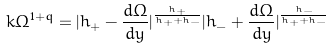<formula> <loc_0><loc_0><loc_500><loc_500>k \Omega ^ { 1 + q } = | h _ { + } - \frac { d \Omega } { d y } | ^ { \frac { h _ { + } } { h _ { + } + h _ { - } } } | h _ { - } + \frac { d \Omega } { d y } | ^ { \frac { h _ { - } } { h _ { + } + h _ { - } } }</formula> 